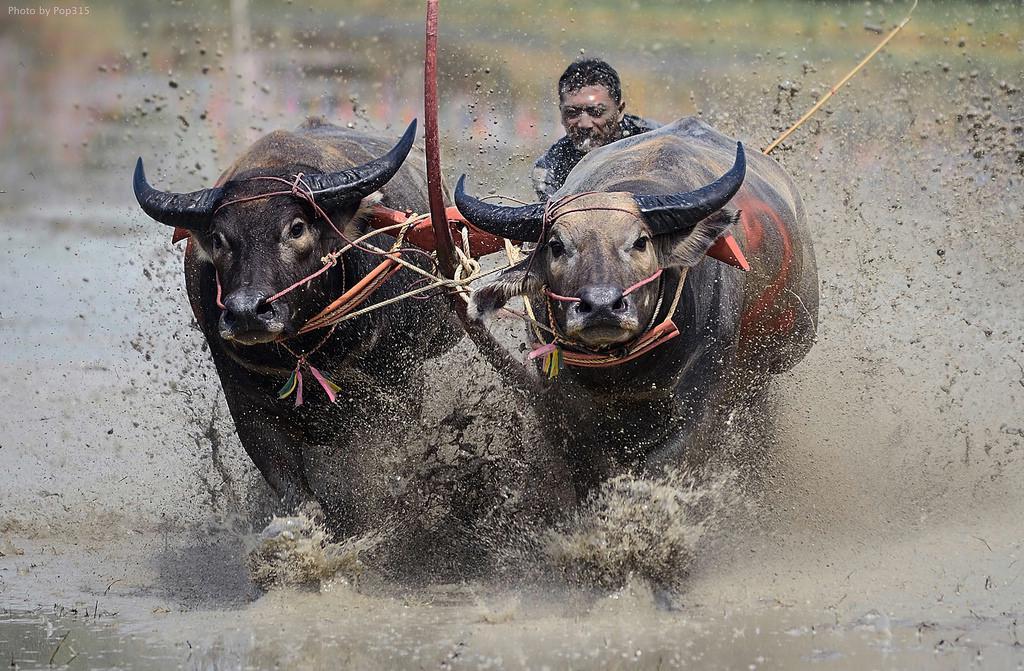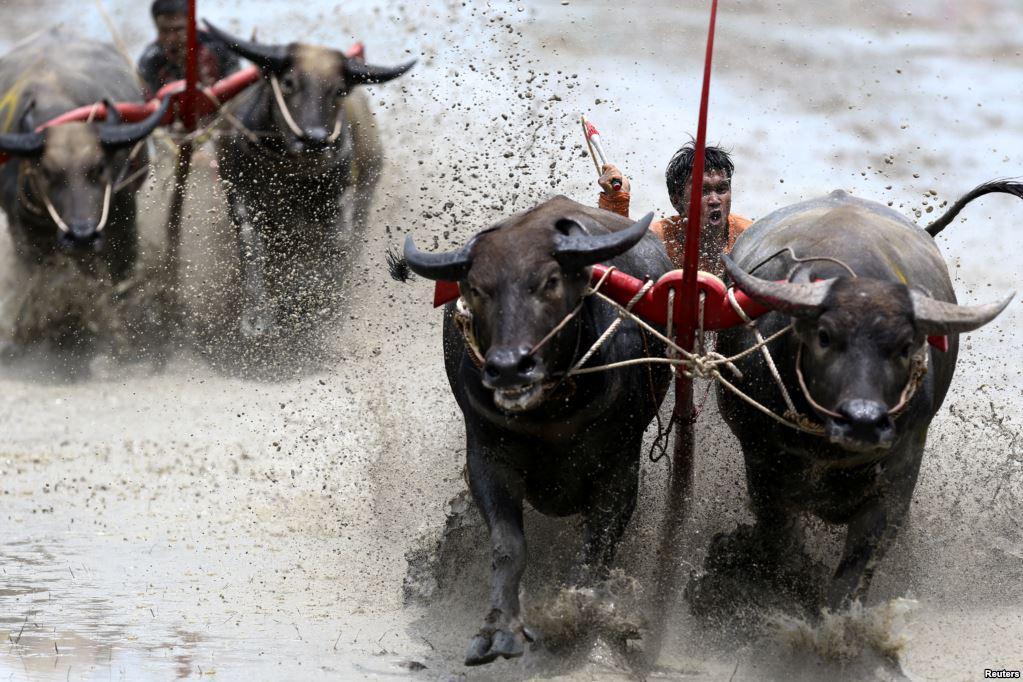The first image is the image on the left, the second image is the image on the right. Assess this claim about the two images: "Each image features a race where a team of two water buffalo is driven forward by a man wielding a stick.". Correct or not? Answer yes or no. Yes. The first image is the image on the left, the second image is the image on the right. Analyze the images presented: Is the assertion "Every single bovine appears to be part of a race." valid? Answer yes or no. Yes. 